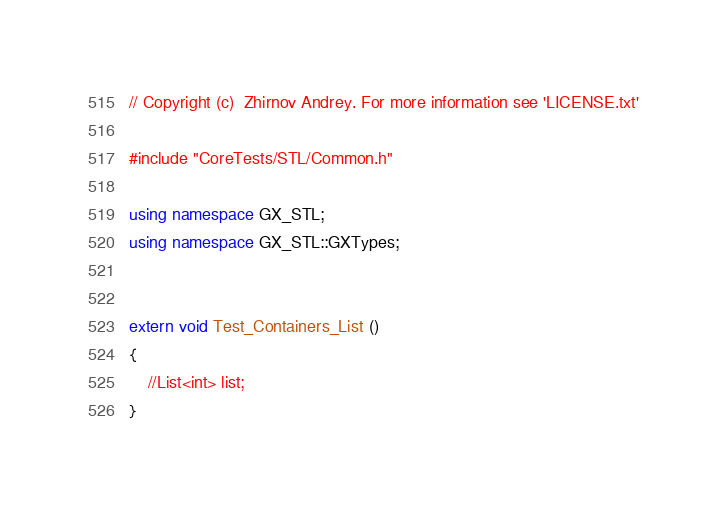<code> <loc_0><loc_0><loc_500><loc_500><_C++_>// Copyright (c)  Zhirnov Andrey. For more information see 'LICENSE.txt'

#include "CoreTests/STL/Common.h"

using namespace GX_STL;
using namespace GX_STL::GXTypes;


extern void Test_Containers_List ()
{
	//List<int>	list;
}
</code> 